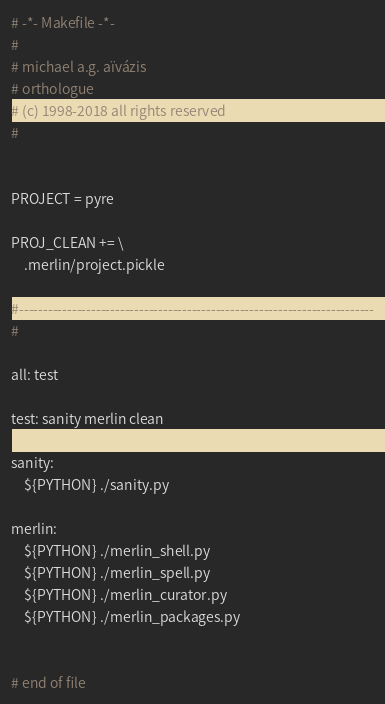<code> <loc_0><loc_0><loc_500><loc_500><_ObjectiveC_># -*- Makefile -*-
#
# michael a.g. aïvázis
# orthologue
# (c) 1998-2018 all rights reserved
#


PROJECT = pyre

PROJ_CLEAN += \
    .merlin/project.pickle

#--------------------------------------------------------------------------
#

all: test

test: sanity merlin clean

sanity:
	${PYTHON} ./sanity.py

merlin:
	${PYTHON} ./merlin_shell.py
	${PYTHON} ./merlin_spell.py
	${PYTHON} ./merlin_curator.py
	${PYTHON} ./merlin_packages.py


# end of file
</code> 